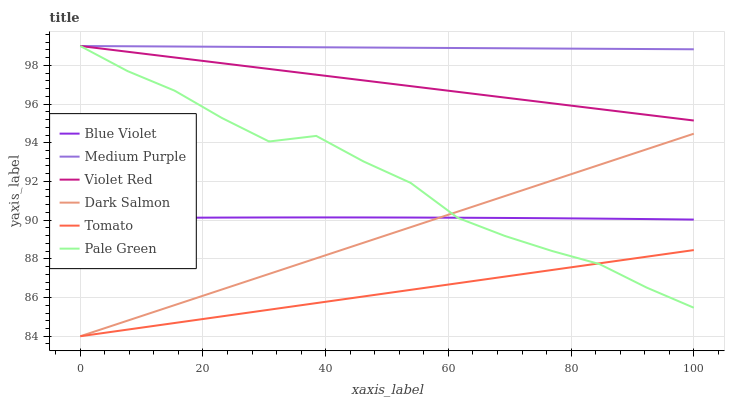Does Violet Red have the minimum area under the curve?
Answer yes or no. No. Does Violet Red have the maximum area under the curve?
Answer yes or no. No. Is Dark Salmon the smoothest?
Answer yes or no. No. Is Dark Salmon the roughest?
Answer yes or no. No. Does Violet Red have the lowest value?
Answer yes or no. No. Does Dark Salmon have the highest value?
Answer yes or no. No. Is Tomato less than Medium Purple?
Answer yes or no. Yes. Is Medium Purple greater than Tomato?
Answer yes or no. Yes. Does Tomato intersect Medium Purple?
Answer yes or no. No. 